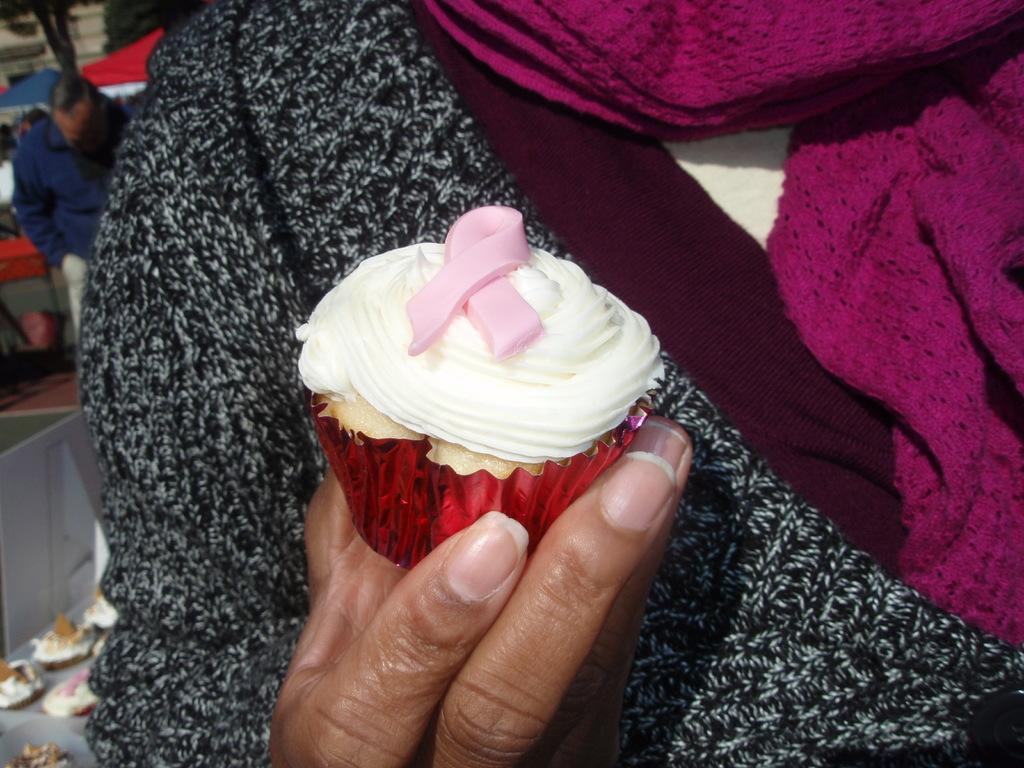What is the person in the image holding? The person is holding a cupcake in the image. Can you describe the background of the image? In the background of the image, there is a man standing, umbrellas, trees, and cupcakes. How many cupcakes can be seen in the image? There is one cupcake held by the person and additional cupcakes visible in the background, so there are at least two cupcakes in the image. What type of bat is hanging from the tree in the image? There is no bat present in the image; it features a person holding a cupcake and various background elements, but no bats. 